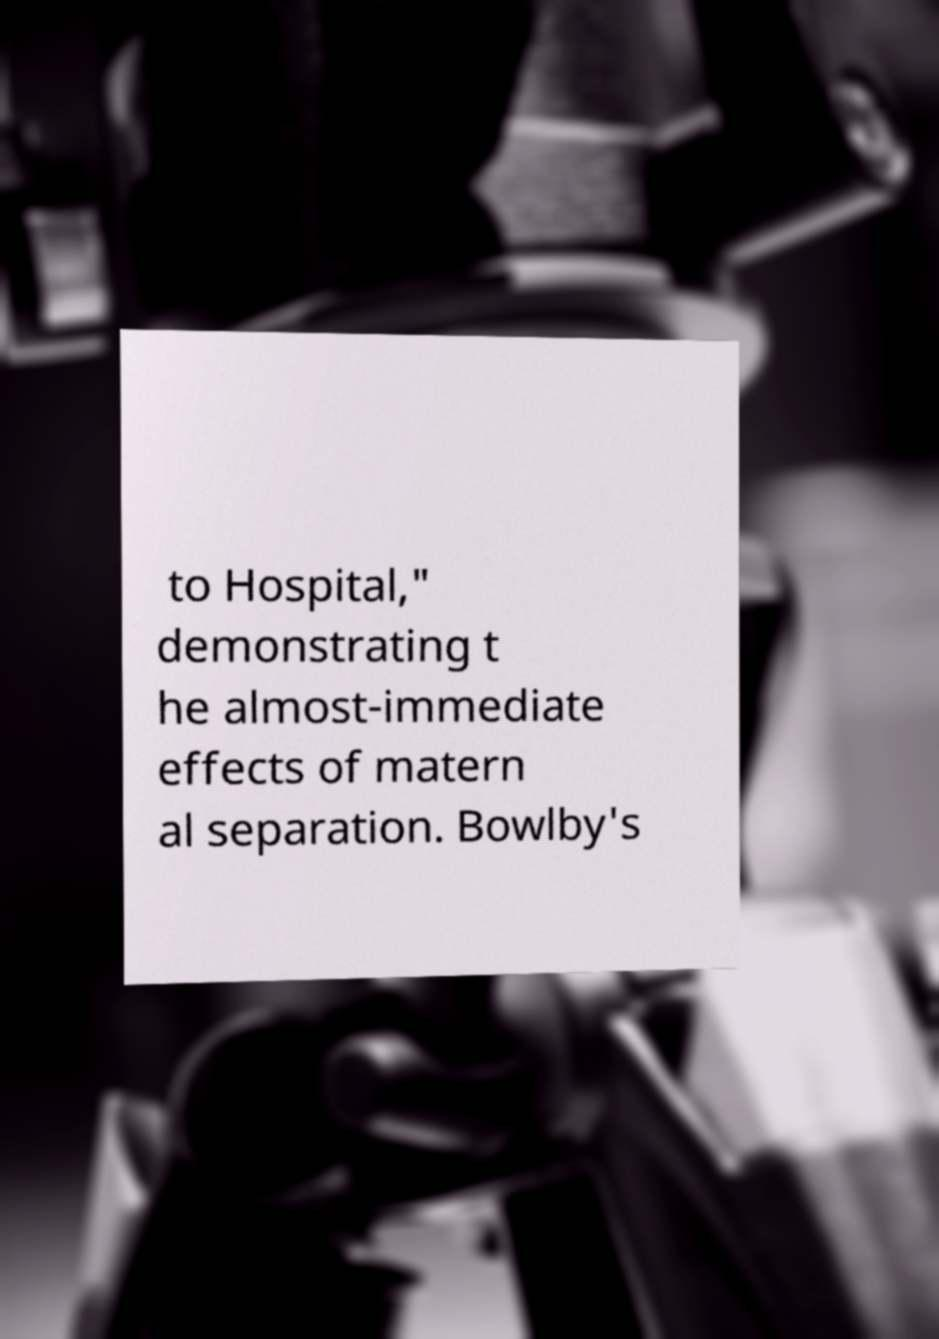Could you extract and type out the text from this image? to Hospital," demonstrating t he almost-immediate effects of matern al separation. Bowlby's 